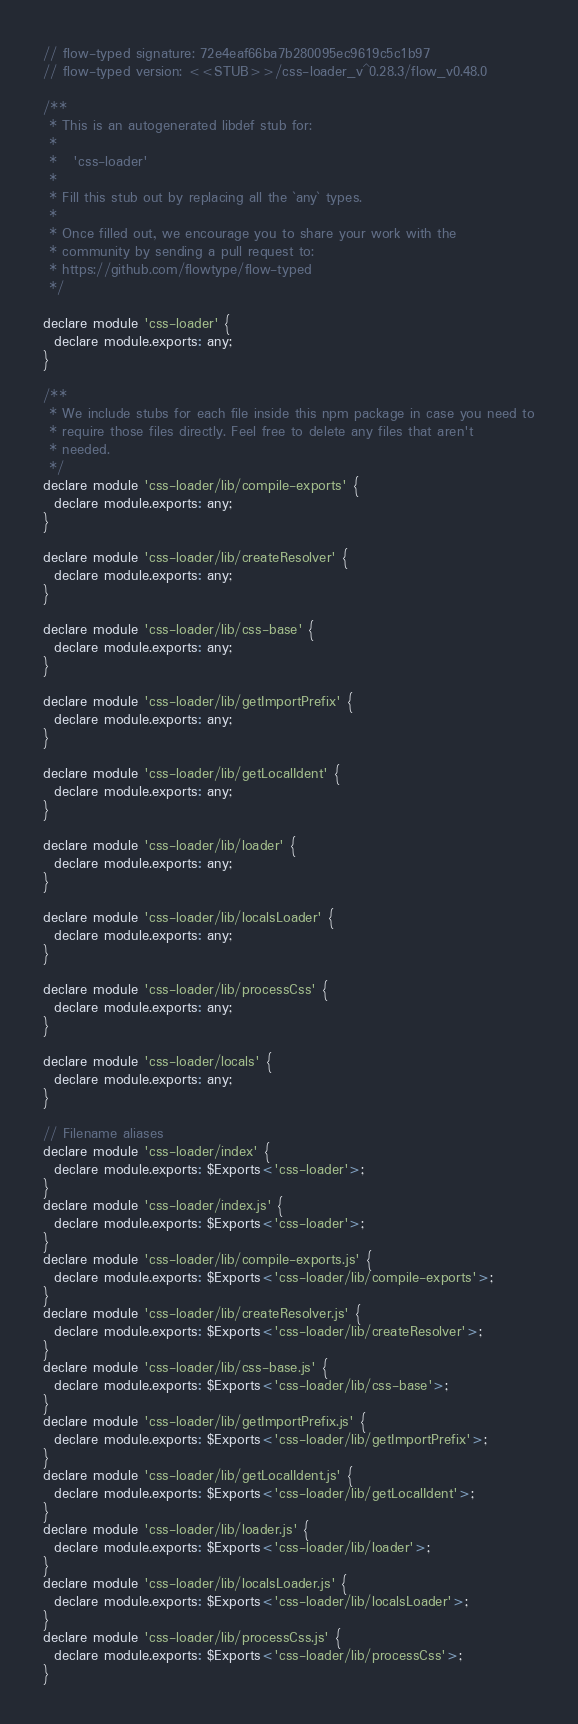<code> <loc_0><loc_0><loc_500><loc_500><_JavaScript_>// flow-typed signature: 72e4eaf66ba7b280095ec9619c5c1b97
// flow-typed version: <<STUB>>/css-loader_v^0.28.3/flow_v0.48.0

/**
 * This is an autogenerated libdef stub for:
 *
 *   'css-loader'
 *
 * Fill this stub out by replacing all the `any` types.
 *
 * Once filled out, we encourage you to share your work with the
 * community by sending a pull request to:
 * https://github.com/flowtype/flow-typed
 */

declare module 'css-loader' {
  declare module.exports: any;
}

/**
 * We include stubs for each file inside this npm package in case you need to
 * require those files directly. Feel free to delete any files that aren't
 * needed.
 */
declare module 'css-loader/lib/compile-exports' {
  declare module.exports: any;
}

declare module 'css-loader/lib/createResolver' {
  declare module.exports: any;
}

declare module 'css-loader/lib/css-base' {
  declare module.exports: any;
}

declare module 'css-loader/lib/getImportPrefix' {
  declare module.exports: any;
}

declare module 'css-loader/lib/getLocalIdent' {
  declare module.exports: any;
}

declare module 'css-loader/lib/loader' {
  declare module.exports: any;
}

declare module 'css-loader/lib/localsLoader' {
  declare module.exports: any;
}

declare module 'css-loader/lib/processCss' {
  declare module.exports: any;
}

declare module 'css-loader/locals' {
  declare module.exports: any;
}

// Filename aliases
declare module 'css-loader/index' {
  declare module.exports: $Exports<'css-loader'>;
}
declare module 'css-loader/index.js' {
  declare module.exports: $Exports<'css-loader'>;
}
declare module 'css-loader/lib/compile-exports.js' {
  declare module.exports: $Exports<'css-loader/lib/compile-exports'>;
}
declare module 'css-loader/lib/createResolver.js' {
  declare module.exports: $Exports<'css-loader/lib/createResolver'>;
}
declare module 'css-loader/lib/css-base.js' {
  declare module.exports: $Exports<'css-loader/lib/css-base'>;
}
declare module 'css-loader/lib/getImportPrefix.js' {
  declare module.exports: $Exports<'css-loader/lib/getImportPrefix'>;
}
declare module 'css-loader/lib/getLocalIdent.js' {
  declare module.exports: $Exports<'css-loader/lib/getLocalIdent'>;
}
declare module 'css-loader/lib/loader.js' {
  declare module.exports: $Exports<'css-loader/lib/loader'>;
}
declare module 'css-loader/lib/localsLoader.js' {
  declare module.exports: $Exports<'css-loader/lib/localsLoader'>;
}
declare module 'css-loader/lib/processCss.js' {
  declare module.exports: $Exports<'css-loader/lib/processCss'>;
}</code> 